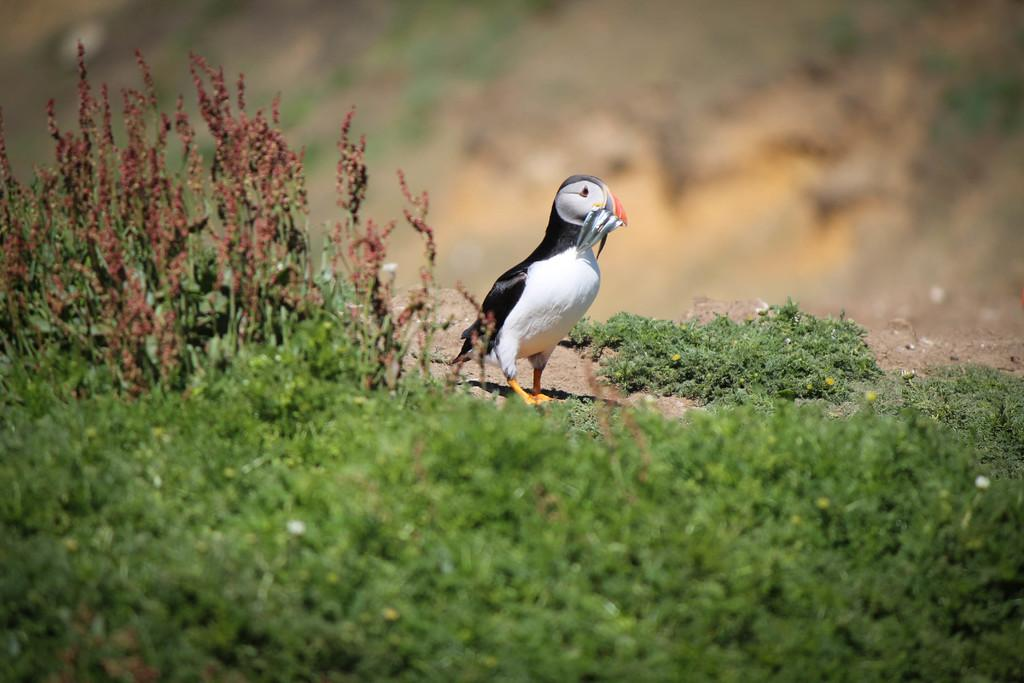What type of vegetation is visible in the front of the image? There is grass in the front of the image. What animal can be seen in the grass? There is a bird standing in the grass. Can you describe the background of the image? The background of the image is blurry. What type of competition is the actor participating in within the image? There is no actor or competition present in the image; it features a bird standing in the grass with a blurry background. 